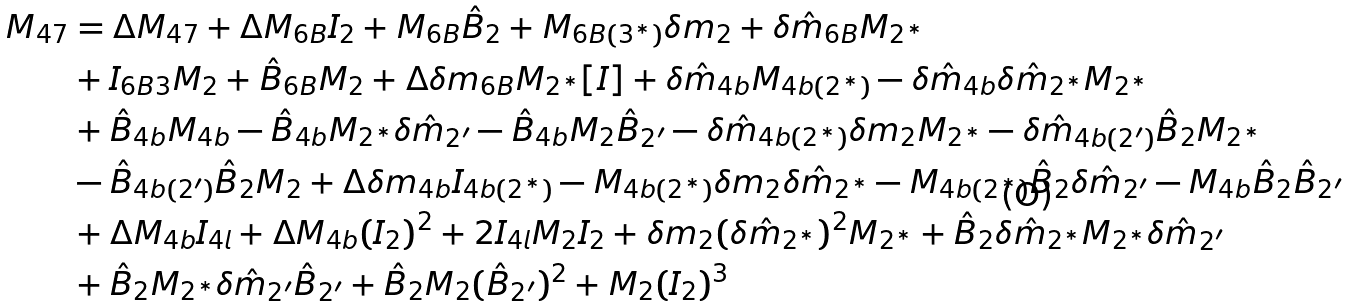Convert formula to latex. <formula><loc_0><loc_0><loc_500><loc_500>M _ { 4 7 } & = \Delta M _ { 4 7 } + \Delta M _ { 6 B } I _ { 2 } + M _ { 6 B } \hat { B } _ { 2 } + M _ { 6 B ( 3 ^ { \ast } ) } \delta m _ { 2 } + \delta \hat { m } _ { 6 B } M _ { 2 ^ { \ast } } \\ & + I _ { 6 B 3 } M _ { 2 } + \hat { B } _ { 6 B } M _ { 2 } + \Delta \delta m _ { 6 B } M _ { 2 ^ { \ast } } [ I ] + \delta \hat { m } _ { 4 b } M _ { 4 b ( 2 ^ { \ast } ) } - \delta \hat { m } _ { 4 b } \delta \hat { m } _ { 2 ^ { \ast } } M _ { 2 ^ { \ast } } \\ & + \hat { B } _ { 4 b } M _ { 4 b } - \hat { B } _ { 4 b } M _ { 2 ^ { \ast } } \delta \hat { m } _ { 2 ^ { \prime } } - \hat { B } _ { 4 b } M _ { 2 } \hat { B } _ { 2 ^ { \prime } } - \delta \hat { m } _ { 4 b ( 2 ^ { \ast } ) } \delta m _ { 2 } M _ { 2 ^ { \ast } } - \delta \hat { m } _ { 4 b ( 2 ^ { \prime } ) } \hat { B } _ { 2 } M _ { 2 ^ { \ast } } \\ & - \hat { B } _ { 4 b ( 2 ^ { \prime } ) } \hat { B } _ { 2 } M _ { 2 } + \Delta \delta m _ { 4 b } I _ { 4 b ( 2 ^ { \ast } ) } - M _ { 4 b ( 2 ^ { \ast } ) } \delta m _ { 2 } \delta \hat { m } _ { 2 ^ { \ast } } - M _ { 4 b ( 2 ^ { \ast } ) } \hat { B } _ { 2 } \delta \hat { m } _ { 2 ^ { \prime } } - M _ { 4 b } \hat { B } _ { 2 } \hat { B } _ { 2 ^ { \prime } } \\ & + \Delta M _ { 4 b } I _ { 4 l } + \Delta M _ { 4 b } ( I _ { 2 } ) ^ { 2 } + 2 I _ { 4 l } M _ { 2 } I _ { 2 } + \delta m _ { 2 } ( \delta \hat { m } _ { 2 ^ { \ast } } ) ^ { 2 } M _ { 2 ^ { \ast } } + \hat { B } _ { 2 } \delta \hat { m } _ { 2 ^ { \ast } } M _ { 2 ^ { \ast } } \delta \hat { m } _ { 2 ^ { \prime } } \\ & + \hat { B } _ { 2 } M _ { 2 ^ { \ast } } \delta \hat { m } _ { 2 ^ { \prime } } \hat { B } _ { 2 ^ { \prime } } + \hat { B } _ { 2 } M _ { 2 } ( \hat { B } _ { 2 ^ { \prime } } ) ^ { 2 } + M _ { 2 } ( I _ { 2 } ) ^ { 3 }</formula> 